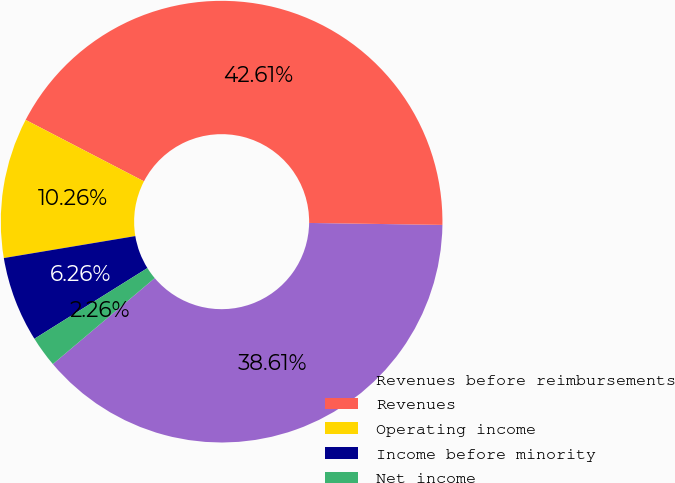<chart> <loc_0><loc_0><loc_500><loc_500><pie_chart><fcel>Revenues before reimbursements<fcel>Revenues<fcel>Operating income<fcel>Income before minority<fcel>Net income<nl><fcel>38.61%<fcel>42.61%<fcel>10.26%<fcel>6.26%<fcel>2.26%<nl></chart> 